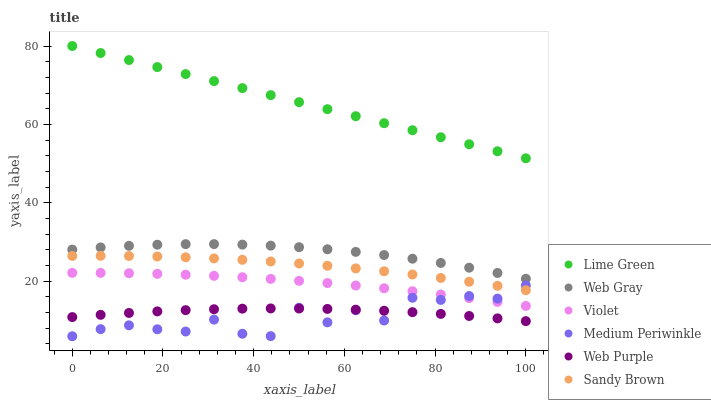Does Medium Periwinkle have the minimum area under the curve?
Answer yes or no. Yes. Does Lime Green have the maximum area under the curve?
Answer yes or no. Yes. Does Sandy Brown have the minimum area under the curve?
Answer yes or no. No. Does Sandy Brown have the maximum area under the curve?
Answer yes or no. No. Is Lime Green the smoothest?
Answer yes or no. Yes. Is Medium Periwinkle the roughest?
Answer yes or no. Yes. Is Sandy Brown the smoothest?
Answer yes or no. No. Is Sandy Brown the roughest?
Answer yes or no. No. Does Medium Periwinkle have the lowest value?
Answer yes or no. Yes. Does Sandy Brown have the lowest value?
Answer yes or no. No. Does Lime Green have the highest value?
Answer yes or no. Yes. Does Sandy Brown have the highest value?
Answer yes or no. No. Is Medium Periwinkle less than Lime Green?
Answer yes or no. Yes. Is Sandy Brown greater than Violet?
Answer yes or no. Yes. Does Sandy Brown intersect Medium Periwinkle?
Answer yes or no. Yes. Is Sandy Brown less than Medium Periwinkle?
Answer yes or no. No. Is Sandy Brown greater than Medium Periwinkle?
Answer yes or no. No. Does Medium Periwinkle intersect Lime Green?
Answer yes or no. No. 